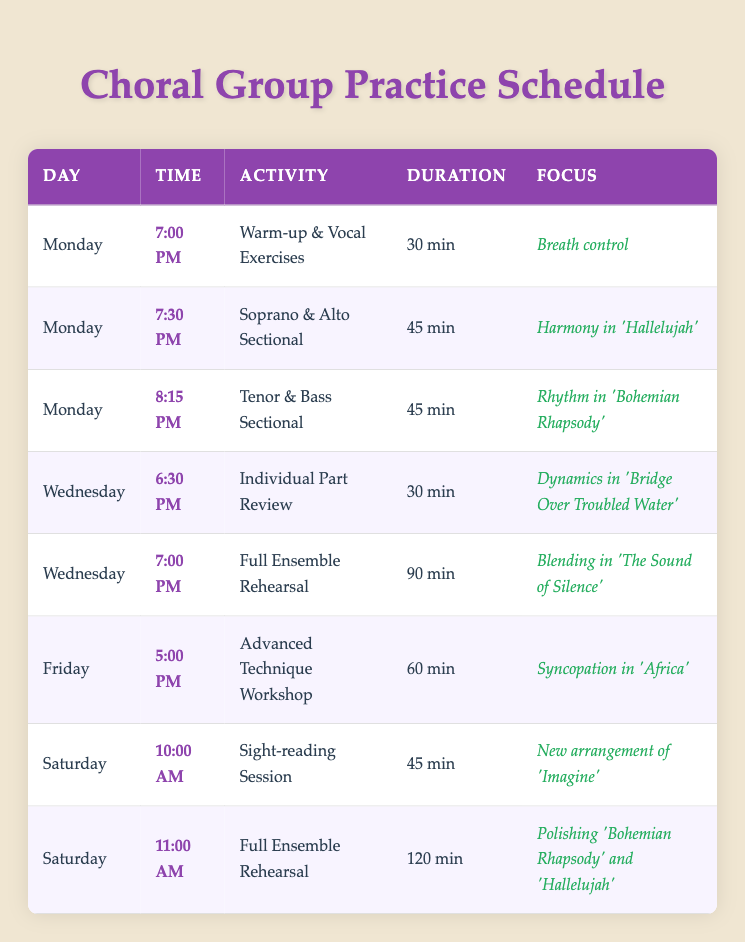What time does the Full Ensemble Rehearsal on Wednesday start? From the table, look at the row where the activity is "Full Ensemble Rehearsal" and find the corresponding day, which is Wednesday. The time listed for this activity is 7:00 PM.
Answer: 7:00 PM How long is the Soprano & Alto Sectional on Monday? The table states that the duration of the Soprano & Alto Sectional activity is 45 min, as can be found in the row corresponding to this activity on Monday.
Answer: 45 min Is there any practice scheduled for Thursday? By examining the table, there are no entries for Thursday listed among the practice sessions, indicating that no activities are scheduled for that day.
Answer: No What is the total duration of all practices on Saturday? Reviewing the Saturday activities, there are two: a Sight-reading Session lasting 45 min and a Full Ensemble Rehearsal lasting 120 min. Adding these together results in 45 min + 120 min = 165 min.
Answer: 165 min Which activity has a focus on "Harmony in 'Hallelujah'" and what day is it scheduled? Checking the table, the activity related to "Harmony in 'Hallelujah'" is the Soprano & Alto Sectional, which takes place on Monday.
Answer: Monday How many different activities are scheduled across the entire week? By counting the unique activities listed in the table, there are 7 activities in total: Warm-up & Vocal Exercises, Soprano & Alto Sectional, Tenor & Bass Sectional, Individual Part Review, Full Ensemble Rehearsal, Advanced Technique Workshop, and Sight-reading Session.
Answer: 7 On what day and time do the Tenor & Bass Sectional start? From the table, you can see that the Tenor & Bass Sectional is scheduled for Monday at 8:15 PM. This information is listed clearly in the row corresponding to this activity.
Answer: Monday at 8:15 PM Which practice session lasts the longest and how long is it? Looking through the table, the Full Ensemble Rehearsal on Saturday is the longest at 120 min, compared to the other durations listed.
Answer: 120 min What focus area is shared by both the Full Ensemble Rehearsals scheduled on Monday and Saturday? In examining the table, both Full Ensemble Rehearsals focus on different aspects: Monday focuses on blending in 'The Sound of Silence' and Saturday focuses on polishing 'Bohemian Rhapsody' and 'Hallelujah.' Thus, they do not share a common focus area.
Answer: No shared focus area 